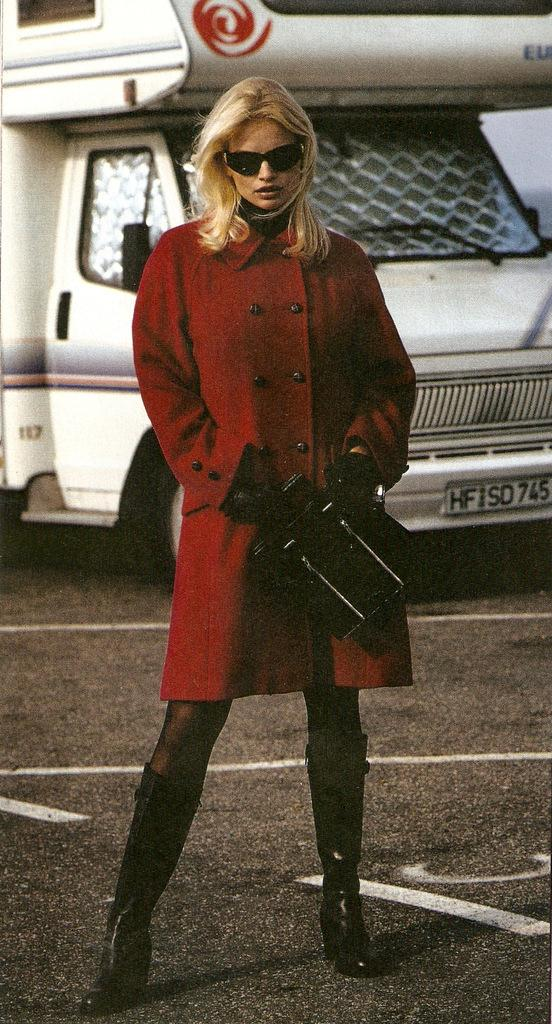Who is the main subject in the image? There is a woman in the image. Where is the woman located in the image? The woman is standing in the middle of the image. What is the woman standing on? The woman is standing on the floor. What is the woman wearing in the image? The woman is wearing a red color dress. What can be seen in the background of the image? There is a truck in the background of the image. How many chickens are present in the image? There are no chickens present in the image. What type of place is depicted in the image? The image does not depict a specific place; it only shows a woman standing on the floor and a truck in the background. 